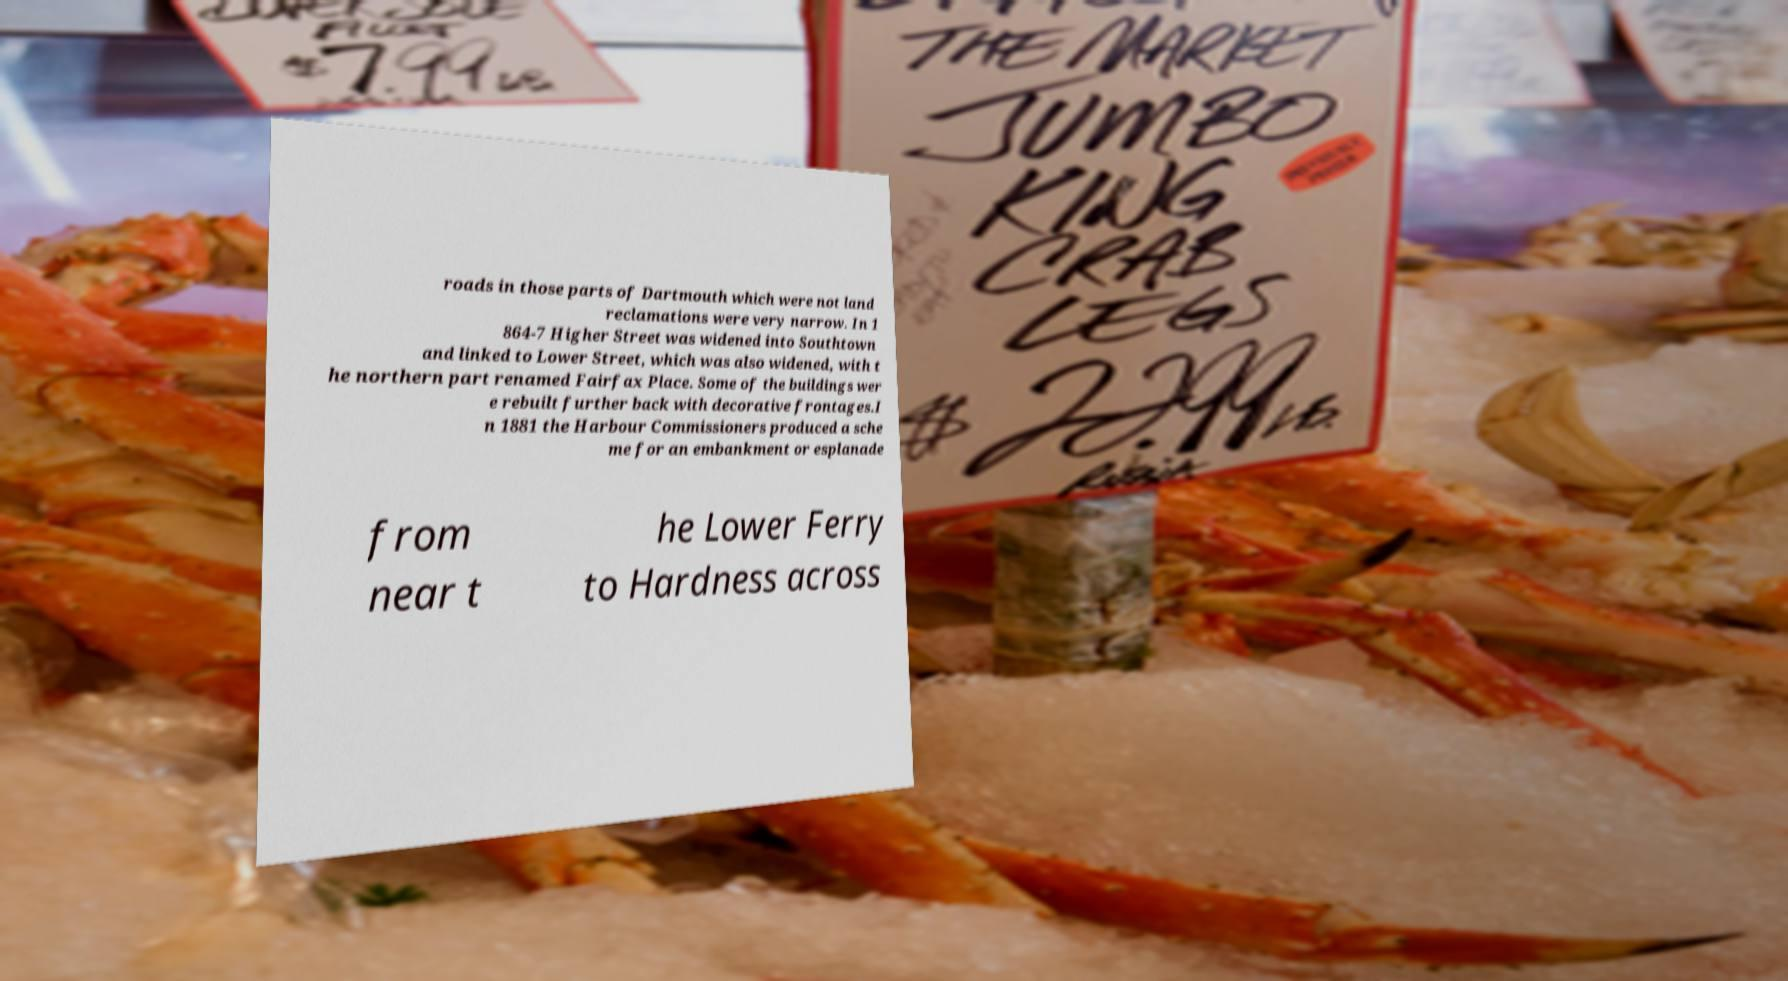Can you read and provide the text displayed in the image?This photo seems to have some interesting text. Can you extract and type it out for me? roads in those parts of Dartmouth which were not land reclamations were very narrow. In 1 864-7 Higher Street was widened into Southtown and linked to Lower Street, which was also widened, with t he northern part renamed Fairfax Place. Some of the buildings wer e rebuilt further back with decorative frontages.I n 1881 the Harbour Commissioners produced a sche me for an embankment or esplanade from near t he Lower Ferry to Hardness across 